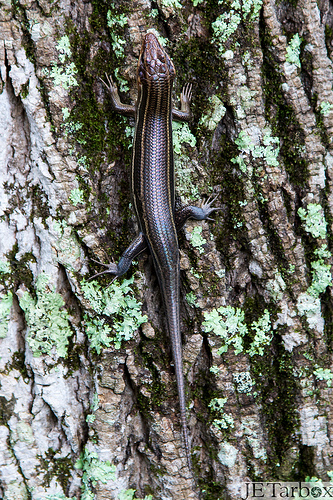<image>
Can you confirm if the lizard is on the tree? Yes. Looking at the image, I can see the lizard is positioned on top of the tree, with the tree providing support. 